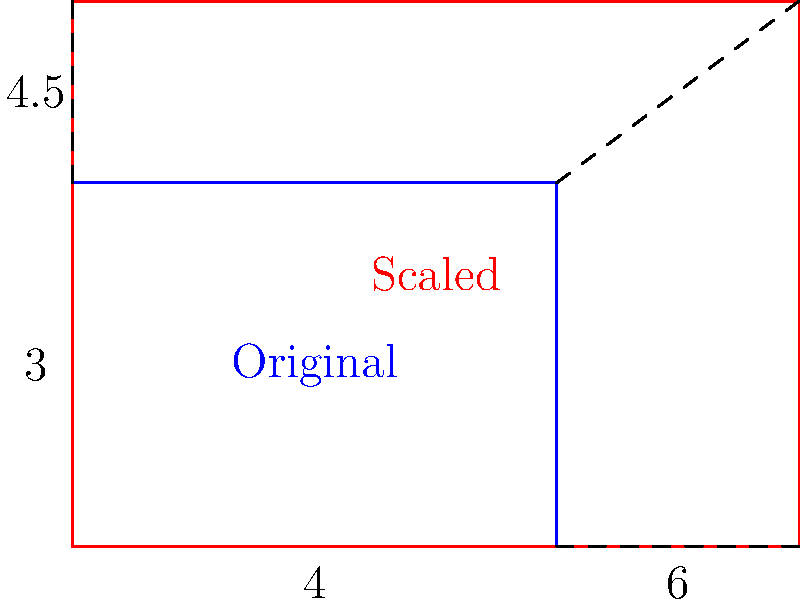A solar farm developer claims that by increasing the dimensions of a rectangular solar farm by 50%, the power output will more than double. Given that the original farm measures 4 units by 3 units and the scaled farm measures 6 units by 4.5 units, determine the factor by which the area (and consequently, the power output) increases. How does this compare to the developer's claim? Let's approach this step-by-step:

1) Original farm dimensions: 4 x 3 units
   Original area: $A_1 = 4 * 3 = 12$ square units

2) Scaled farm dimensions: 6 x 4.5 units
   Scaled area: $A_2 = 6 * 4.5 = 27$ square units

3) To find the factor of increase, we divide the new area by the original area:
   $\text{Factor} = \frac{A_2}{A_1} = \frac{27}{12} = 2.25$

4) This means the area (and consequently, the power output) has increased by a factor of 2.25, or 225%.

5) The developer claimed the power output would "more than double". Doubling would be an increase by a factor of 2 or 200%.

6) Since 2.25 > 2, the developer's claim is technically correct, but it's important to note that the increase is not as dramatic as the "50% increase in dimensions" might suggest.

7) This demonstrates how linear increases in dimensions result in quadratic increases in area, following the square-cube law. However, it also shows how marketing claims in the solar industry can be misleading without proper context.
Answer: The area increases by a factor of 2.25, which supports the developer's claim but may be less impressive than implied. 